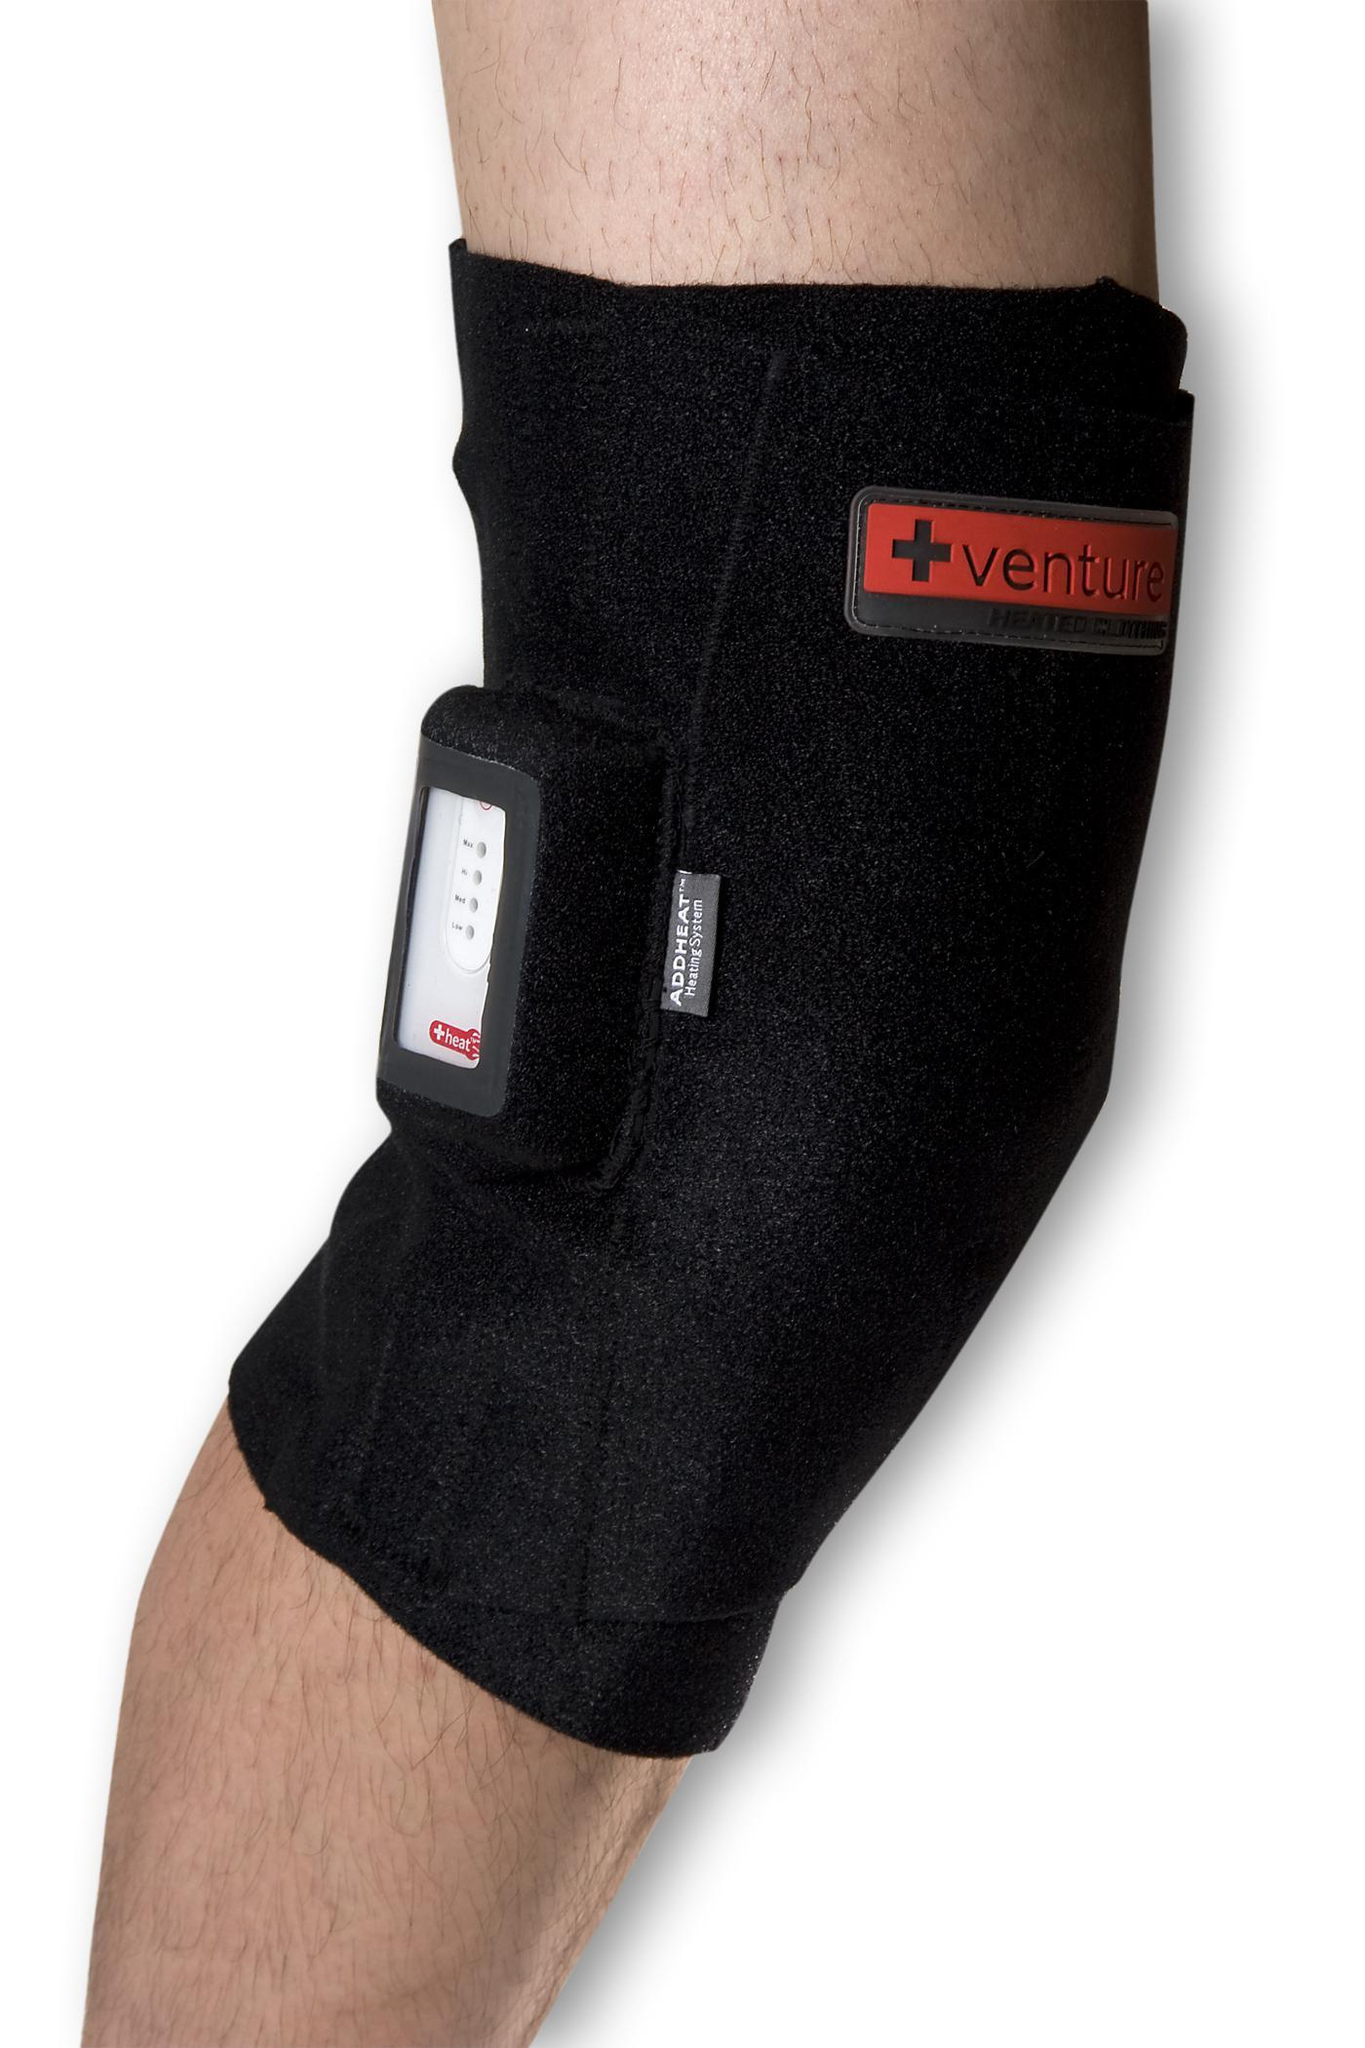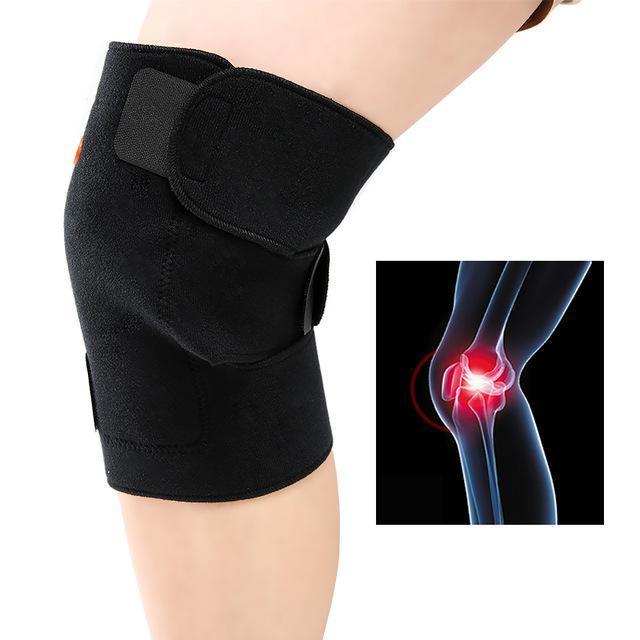The first image is the image on the left, the second image is the image on the right. Assess this claim about the two images: "The left and right image each have at least on all black knee pads minus the labeling.". Correct or not? Answer yes or no. Yes. The first image is the image on the left, the second image is the image on the right. Evaluate the accuracy of this statement regarding the images: "Each image includes at least one human leg with exposed skin, and each human leg wears a knee wrap.". Is it true? Answer yes or no. Yes. 